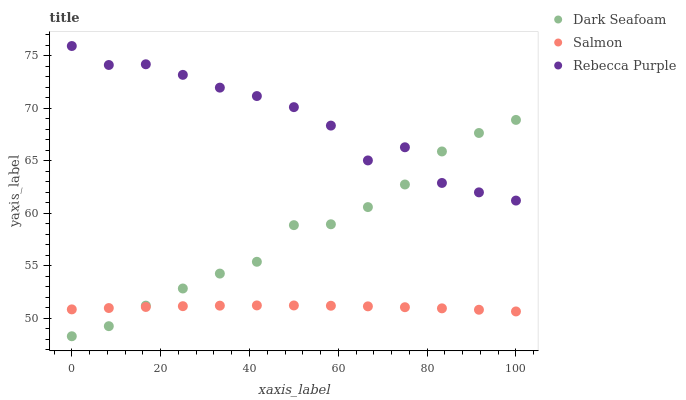Does Salmon have the minimum area under the curve?
Answer yes or no. Yes. Does Rebecca Purple have the maximum area under the curve?
Answer yes or no. Yes. Does Rebecca Purple have the minimum area under the curve?
Answer yes or no. No. Does Salmon have the maximum area under the curve?
Answer yes or no. No. Is Salmon the smoothest?
Answer yes or no. Yes. Is Rebecca Purple the roughest?
Answer yes or no. Yes. Is Rebecca Purple the smoothest?
Answer yes or no. No. Is Salmon the roughest?
Answer yes or no. No. Does Dark Seafoam have the lowest value?
Answer yes or no. Yes. Does Salmon have the lowest value?
Answer yes or no. No. Does Rebecca Purple have the highest value?
Answer yes or no. Yes. Does Salmon have the highest value?
Answer yes or no. No. Is Salmon less than Rebecca Purple?
Answer yes or no. Yes. Is Rebecca Purple greater than Salmon?
Answer yes or no. Yes. Does Dark Seafoam intersect Rebecca Purple?
Answer yes or no. Yes. Is Dark Seafoam less than Rebecca Purple?
Answer yes or no. No. Is Dark Seafoam greater than Rebecca Purple?
Answer yes or no. No. Does Salmon intersect Rebecca Purple?
Answer yes or no. No. 